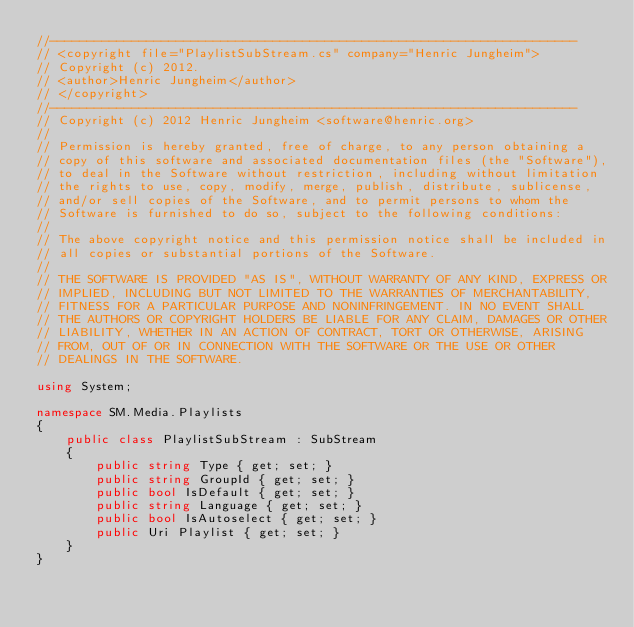Convert code to text. <code><loc_0><loc_0><loc_500><loc_500><_C#_>//-----------------------------------------------------------------------
// <copyright file="PlaylistSubStream.cs" company="Henric Jungheim">
// Copyright (c) 2012.
// <author>Henric Jungheim</author>
// </copyright>
//-----------------------------------------------------------------------
// Copyright (c) 2012 Henric Jungheim <software@henric.org> 
//
// Permission is hereby granted, free of charge, to any person obtaining a
// copy of this software and associated documentation files (the "Software"),
// to deal in the Software without restriction, including without limitation
// the rights to use, copy, modify, merge, publish, distribute, sublicense,
// and/or sell copies of the Software, and to permit persons to whom the
// Software is furnished to do so, subject to the following conditions:
//
// The above copyright notice and this permission notice shall be included in
// all copies or substantial portions of the Software.
//
// THE SOFTWARE IS PROVIDED "AS IS", WITHOUT WARRANTY OF ANY KIND, EXPRESS OR
// IMPLIED, INCLUDING BUT NOT LIMITED TO THE WARRANTIES OF MERCHANTABILITY,
// FITNESS FOR A PARTICULAR PURPOSE AND NONINFRINGEMENT. IN NO EVENT SHALL
// THE AUTHORS OR COPYRIGHT HOLDERS BE LIABLE FOR ANY CLAIM, DAMAGES OR OTHER
// LIABILITY, WHETHER IN AN ACTION OF CONTRACT, TORT OR OTHERWISE, ARISING
// FROM, OUT OF OR IN CONNECTION WITH THE SOFTWARE OR THE USE OR OTHER
// DEALINGS IN THE SOFTWARE.

using System;

namespace SM.Media.Playlists
{
    public class PlaylistSubStream : SubStream
    {
        public string Type { get; set; }
        public string GroupId { get; set; }
        public bool IsDefault { get; set; }
        public string Language { get; set; }
        public bool IsAutoselect { get; set; }
        public Uri Playlist { get; set; }
    }
}
</code> 